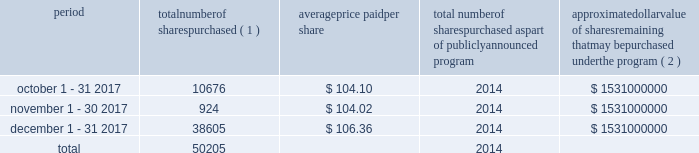Table of contents celanese purchases of its equity securities information regarding repurchases of our common stock during the three months ended december 31 , 2017 is as follows : period number of shares purchased ( 1 ) average price paid per share total number of shares purchased as part of publicly announced program approximate dollar value of shares remaining that may be purchased under the program ( 2 ) .
___________________________ ( 1 ) represents shares withheld from employees to cover their statutory minimum withholding requirements for personal income taxes related to the vesting of restricted stock units .
( 2 ) our board of directors has authorized the aggregate repurchase of $ 3.9 billion of our common stock since february 2008 , including an increase of $ 1.5 billion on july 17 , 2017 .
See note 17 - stockholders' equity in the accompanying consolidated financial statements for further information. .
What is the total value of purchased shares during november 2017? 
Computations: (924 * 104.02)
Answer: 96114.48. 